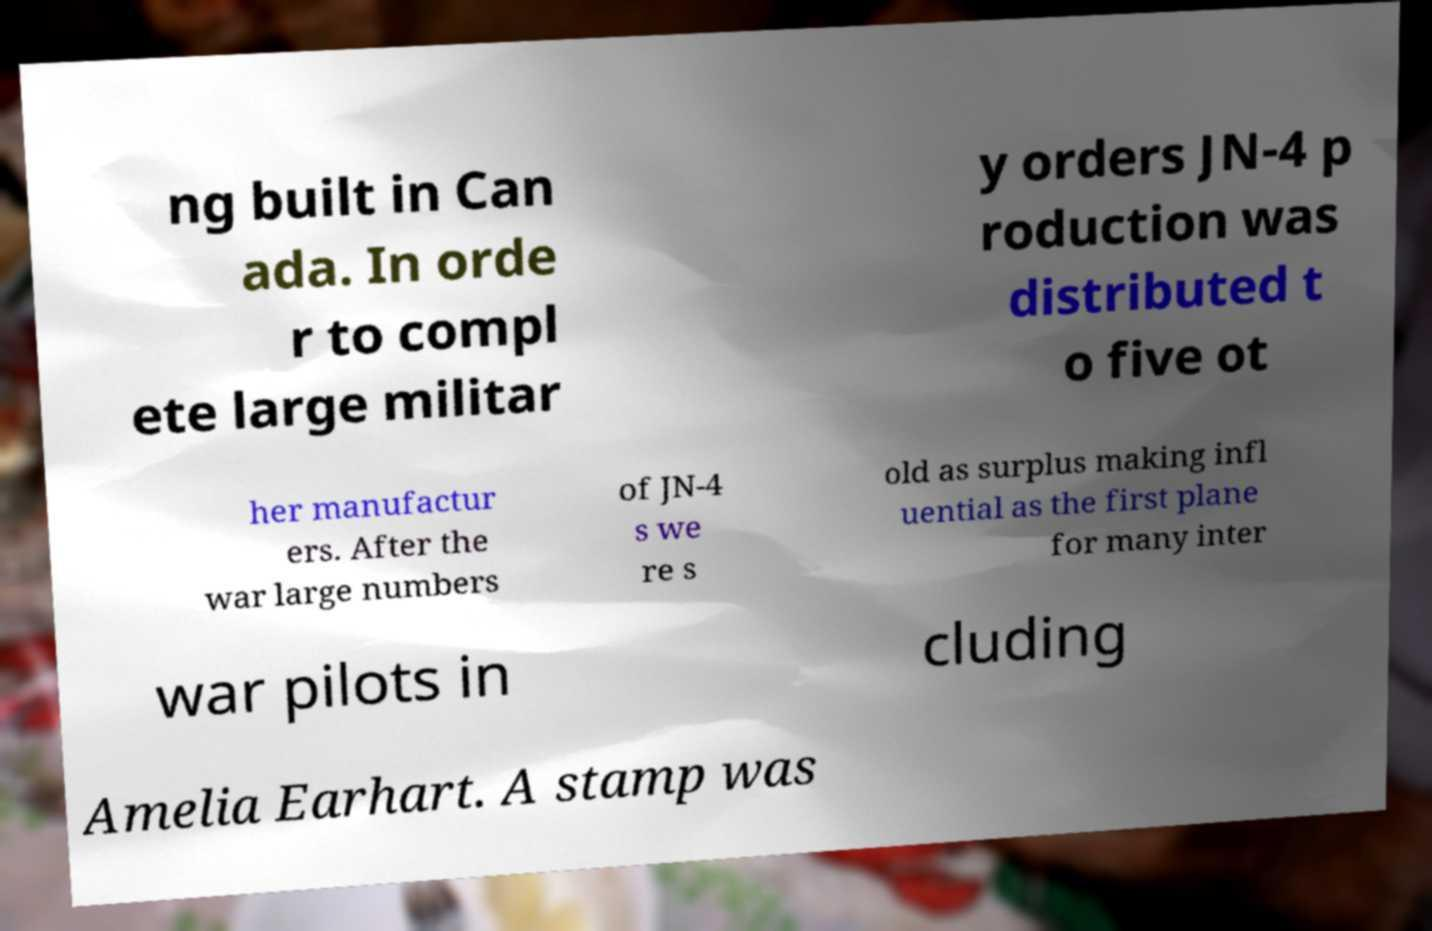Please identify and transcribe the text found in this image. ng built in Can ada. In orde r to compl ete large militar y orders JN-4 p roduction was distributed t o five ot her manufactur ers. After the war large numbers of JN-4 s we re s old as surplus making infl uential as the first plane for many inter war pilots in cluding Amelia Earhart. A stamp was 